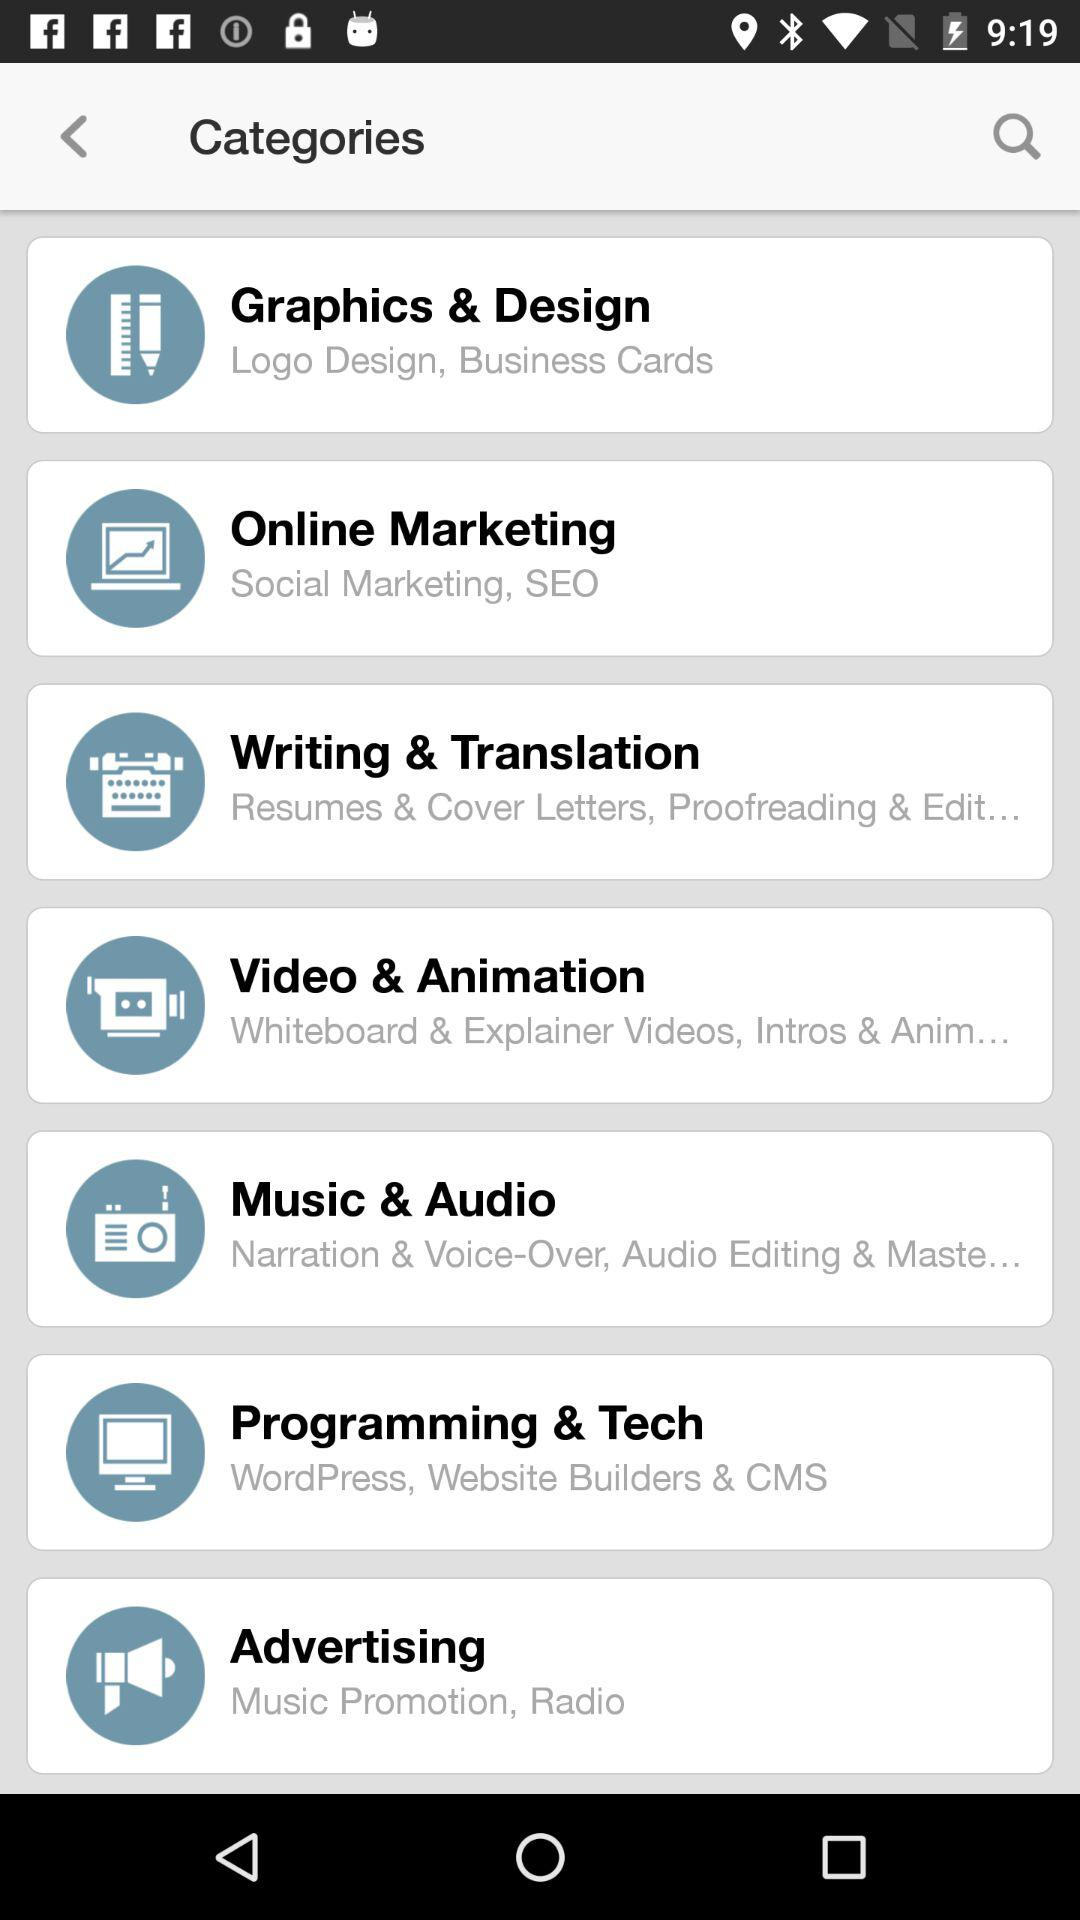What is written in "Writing & Translation"? In Writing & Translation, it is written "Resumes & Cover Letters, Proofreading & Editing...". 